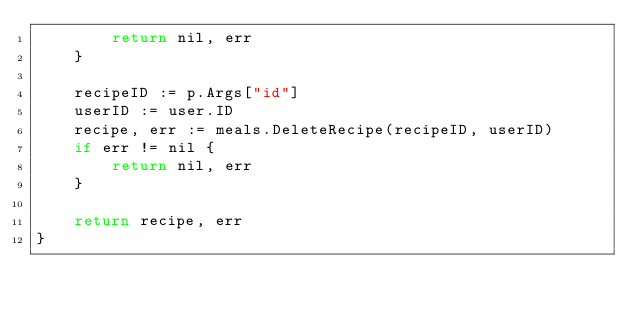Convert code to text. <code><loc_0><loc_0><loc_500><loc_500><_Go_>		return nil, err
	}

	recipeID := p.Args["id"]
	userID := user.ID
	recipe, err := meals.DeleteRecipe(recipeID, userID)
	if err != nil {
		return nil, err
	}

	return recipe, err
}
</code> 